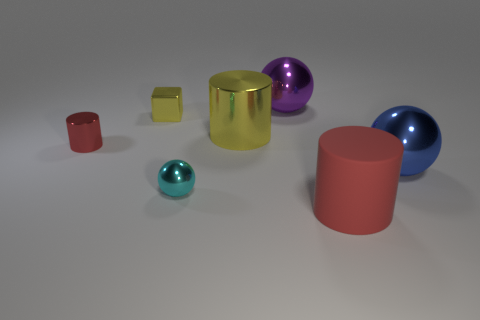Add 2 tiny cyan objects. How many objects exist? 9 Subtract all blocks. How many objects are left? 6 Add 5 large rubber cylinders. How many large rubber cylinders exist? 6 Subtract 2 red cylinders. How many objects are left? 5 Subtract all yellow cylinders. Subtract all small things. How many objects are left? 3 Add 2 tiny metal things. How many tiny metal things are left? 5 